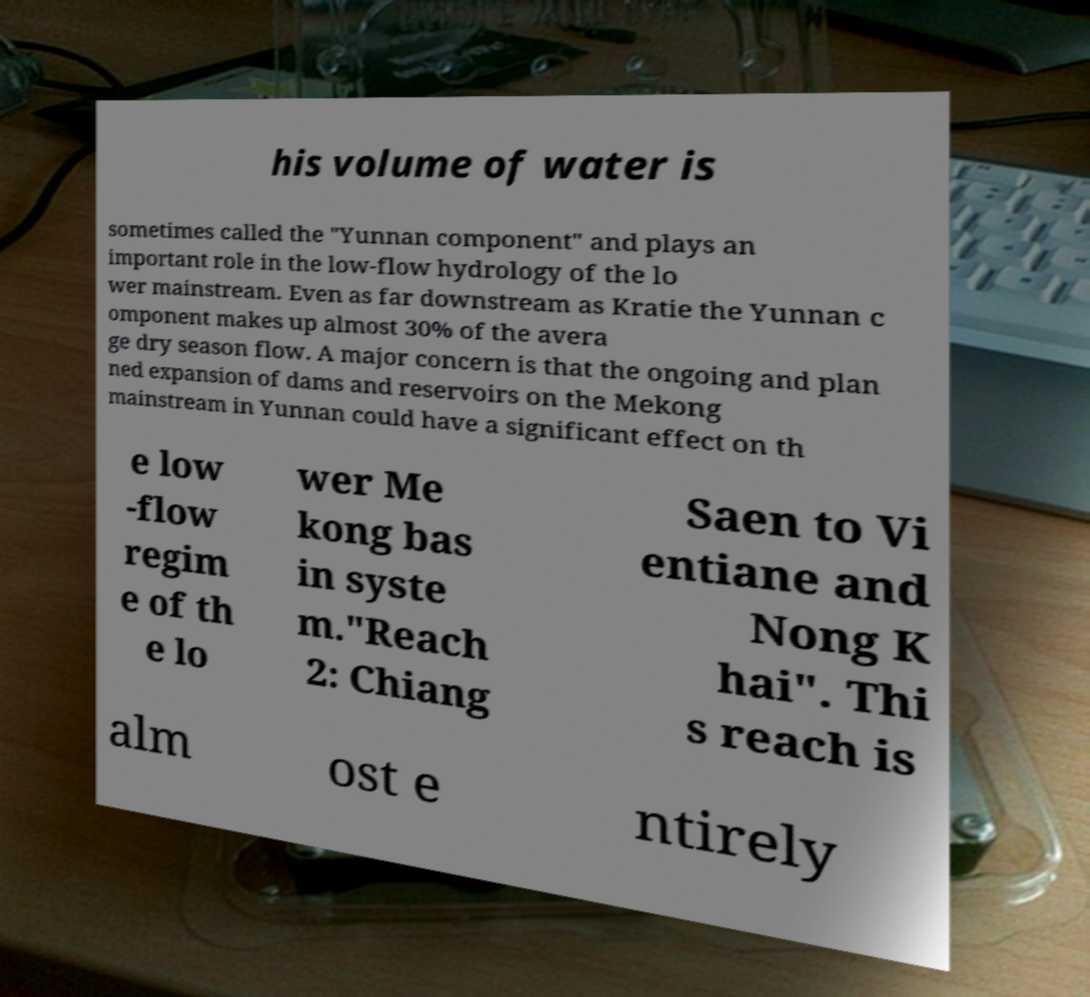Please read and relay the text visible in this image. What does it say? his volume of water is sometimes called the "Yunnan component" and plays an important role in the low-flow hydrology of the lo wer mainstream. Even as far downstream as Kratie the Yunnan c omponent makes up almost 30% of the avera ge dry season flow. A major concern is that the ongoing and plan ned expansion of dams and reservoirs on the Mekong mainstream in Yunnan could have a significant effect on th e low -flow regim e of th e lo wer Me kong bas in syste m."Reach 2: Chiang Saen to Vi entiane and Nong K hai". Thi s reach is alm ost e ntirely 